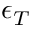Convert formula to latex. <formula><loc_0><loc_0><loc_500><loc_500>\epsilon _ { T }</formula> 